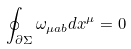<formula> <loc_0><loc_0><loc_500><loc_500>\oint _ { \partial \Sigma } \omega _ { \mu a b } d x ^ { \mu } = 0</formula> 